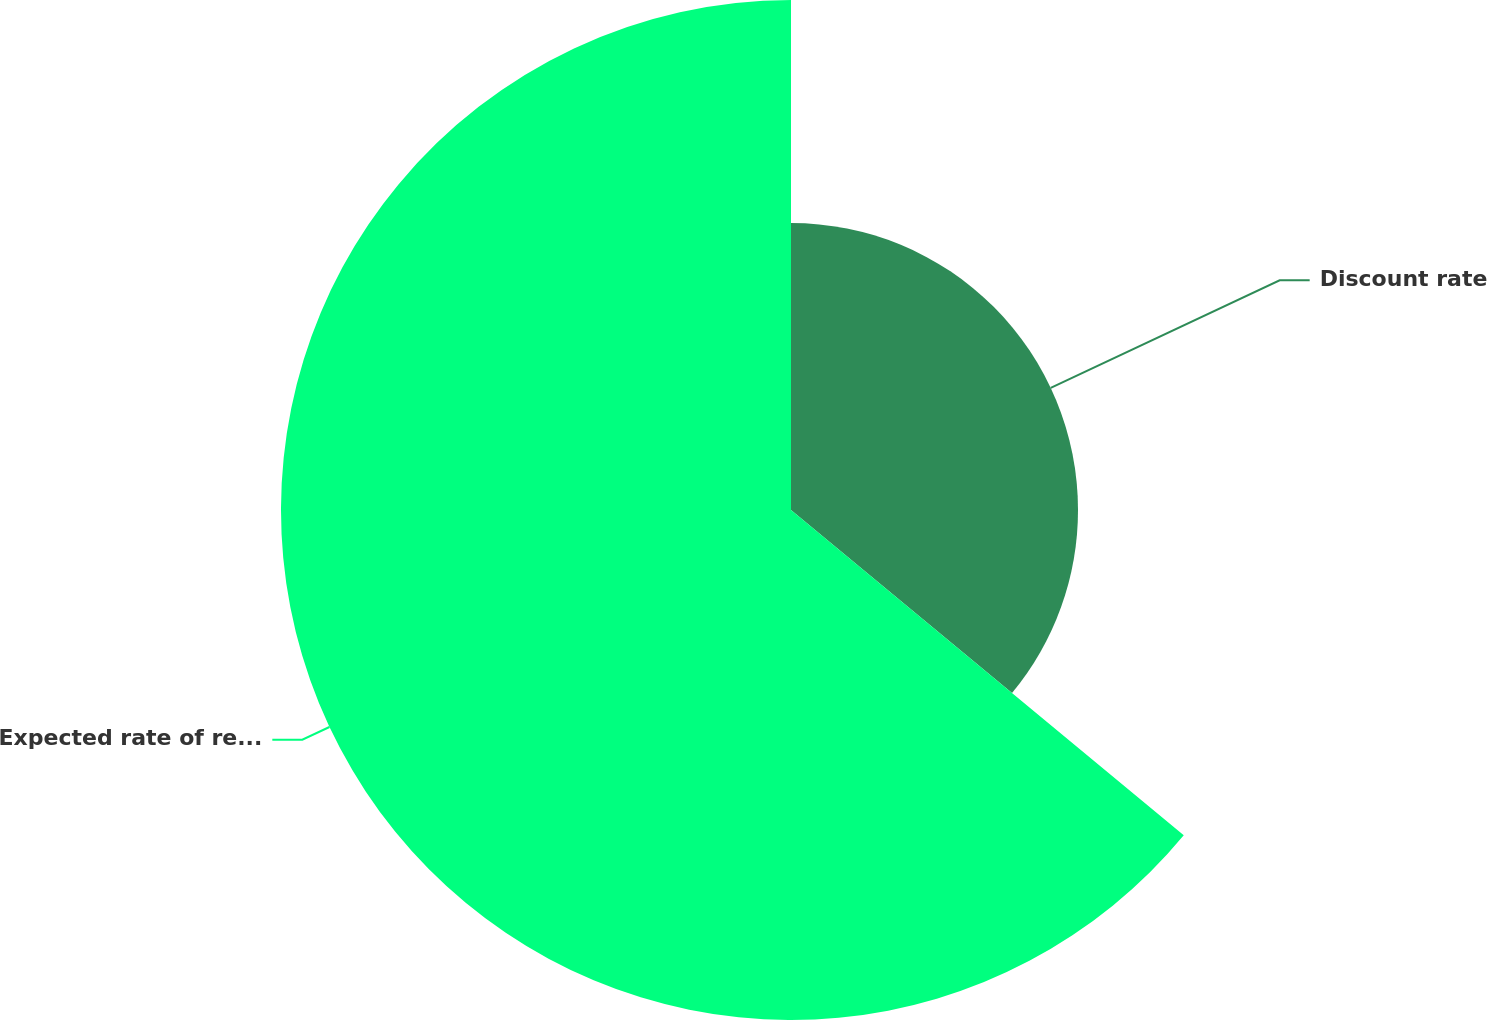Convert chart. <chart><loc_0><loc_0><loc_500><loc_500><pie_chart><fcel>Discount rate<fcel>Expected rate of return on<nl><fcel>36.01%<fcel>63.99%<nl></chart> 